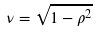Convert formula to latex. <formula><loc_0><loc_0><loc_500><loc_500>\nu = \sqrt { 1 - \rho ^ { 2 } }</formula> 